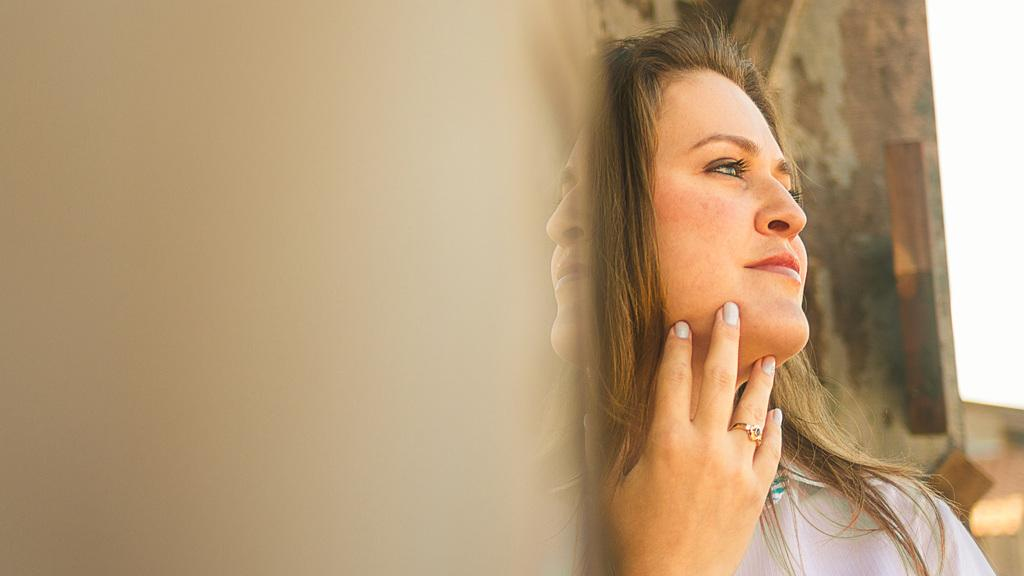Who is present in the image? There is a woman in the image. What is the woman wearing on her finger? The woman is wearing a ring on her finger. What can be seen in the background of the image? There is a building and the sky visible in the background of the image. What time of day is the kitty waking up in the image? There is no kitty present in the image, so it is not possible to determine the time of day it might be waking up. 